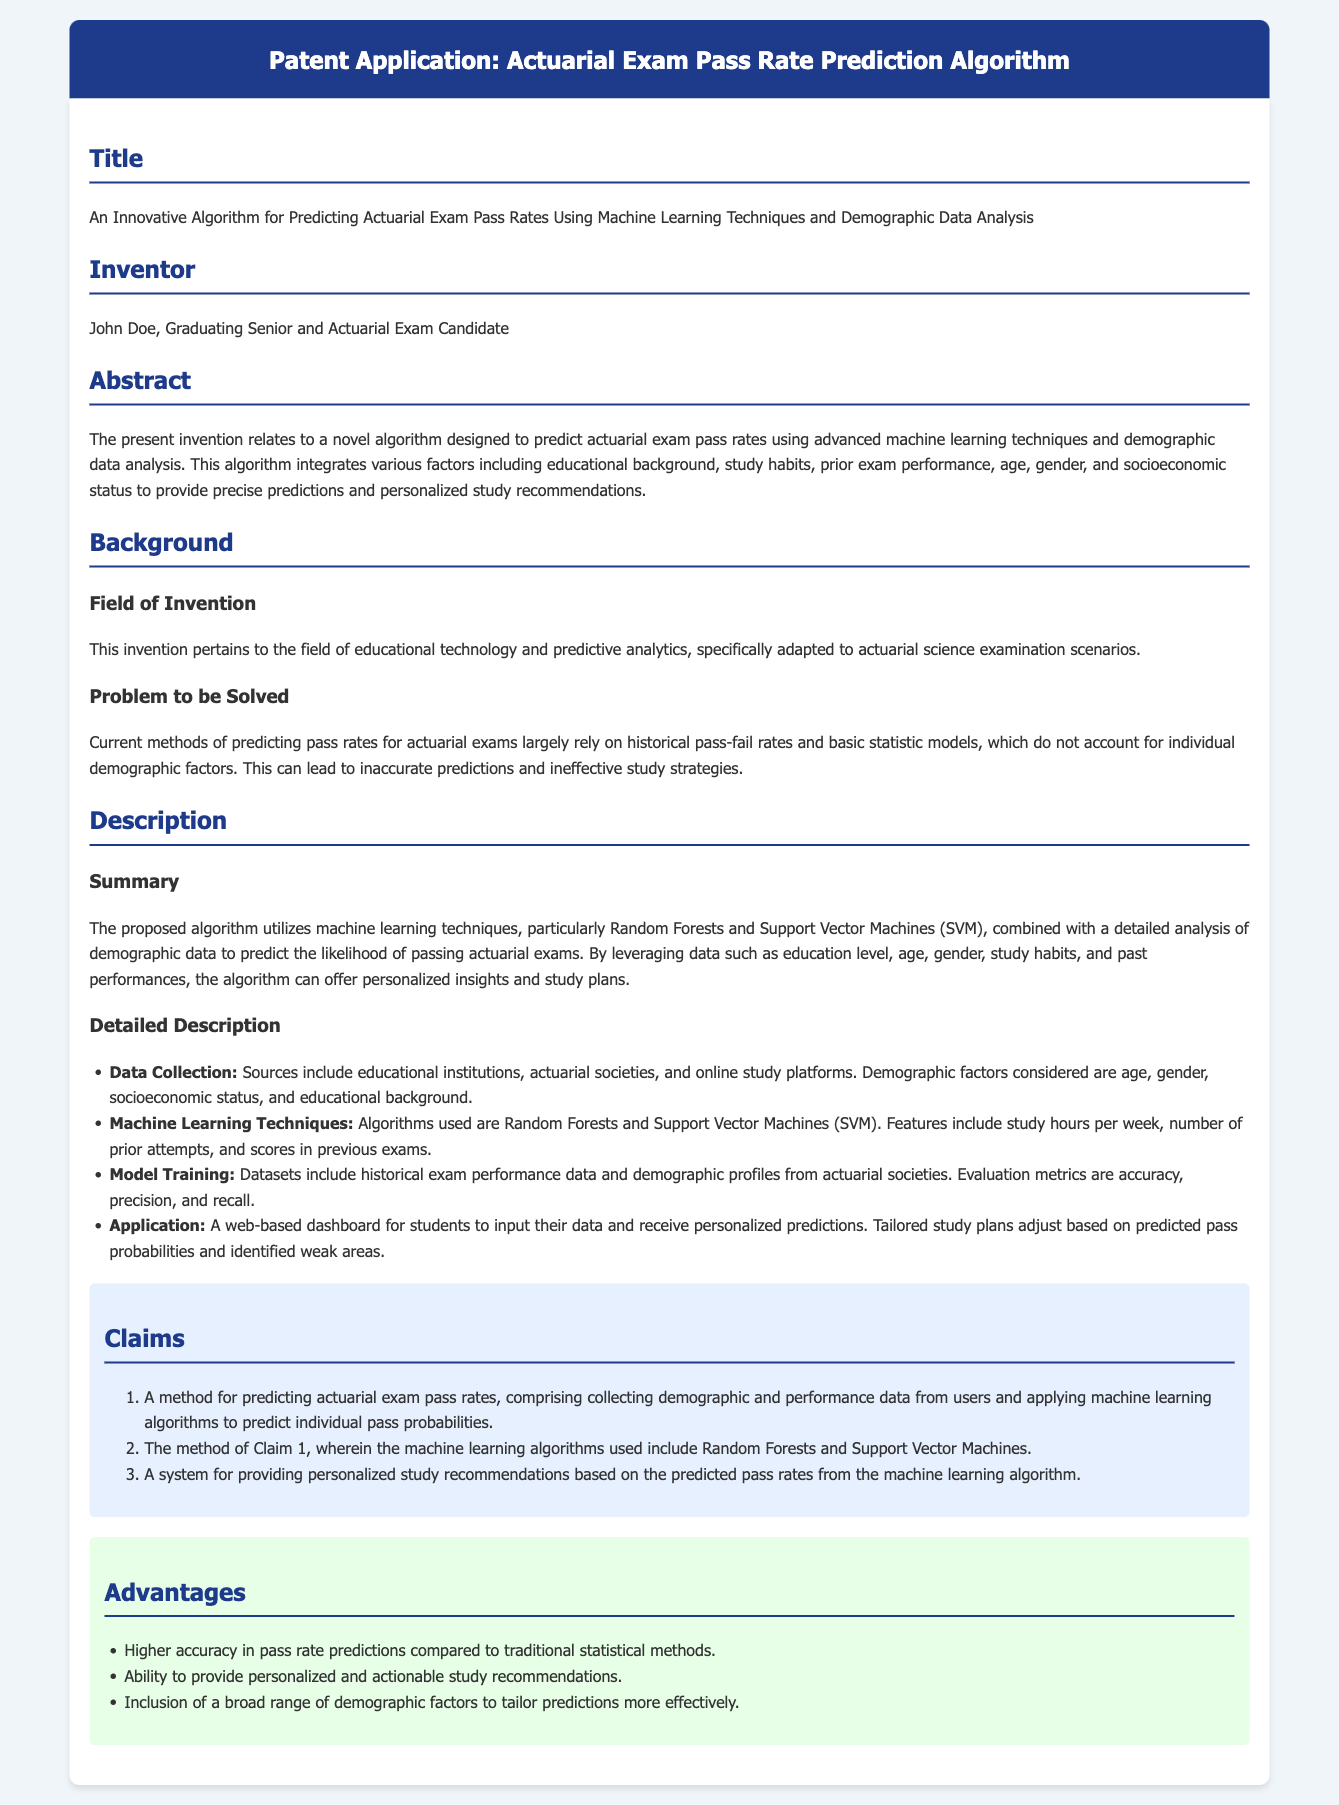what is the title of the patent application? The title of the patent application is listed in the document under the "Title" section.
Answer: An Innovative Algorithm for Predicting Actuarial Exam Pass Rates Using Machine Learning Techniques and Demographic Data Analysis who is the inventor of the algorithm? The name of the inventor is provided in the "Inventor" section of the document.
Answer: John Doe what machine learning techniques are used in the algorithm? The document specifies the machine learning techniques employed in the algorithm under the "Detailed Description" section.
Answer: Random Forests and Support Vector Machines what factors does the algorithm consider for predictions? The document outlines the factors included for predictions in the "Summary" section.
Answer: Educational background, study habits, prior exam performance, age, gender, and socioeconomic status how does the algorithm deliver personalized recommendations? The method of providing personalized recommendations is described in the "Application" section of the document.
Answer: A web-based dashboard for students to input their data what is the purpose of the claims in the document? The purpose of the claims is detailed in the "Claims" section, indicating their role in defining the invention's scope.
Answer: They outline the method and system for predicting pass rates and providing recommendations what are the advantages of this algorithm compared to traditional methods? The advantages are summarized in the "Advantages" section of the document.
Answer: Higher accuracy, personalized recommendations, inclusion of demographic factors 